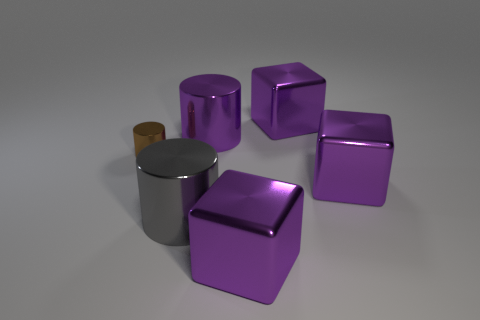Do the gray thing and the small brown metal object have the same shape?
Give a very brief answer. Yes. The other big cylinder that is made of the same material as the gray cylinder is what color?
Provide a short and direct response. Purple. What number of things are either large purple metal objects in front of the large gray metal cylinder or large objects?
Offer a terse response. 5. What is the size of the brown shiny object that is on the left side of the large gray metallic cylinder?
Give a very brief answer. Small. There is a purple cylinder; is its size the same as the cube that is in front of the large gray cylinder?
Ensure brevity in your answer.  Yes. What color is the big shiny cylinder that is in front of the cylinder that is to the right of the big gray thing?
Provide a succinct answer. Gray. How many other objects are the same color as the small thing?
Keep it short and to the point. 0. The brown metallic thing has what size?
Keep it short and to the point. Small. Are there more cylinders that are right of the tiny shiny thing than big purple metal blocks that are to the left of the large gray cylinder?
Your answer should be compact. Yes. How many big blocks are behind the big cube in front of the gray metal thing?
Offer a terse response. 2. 